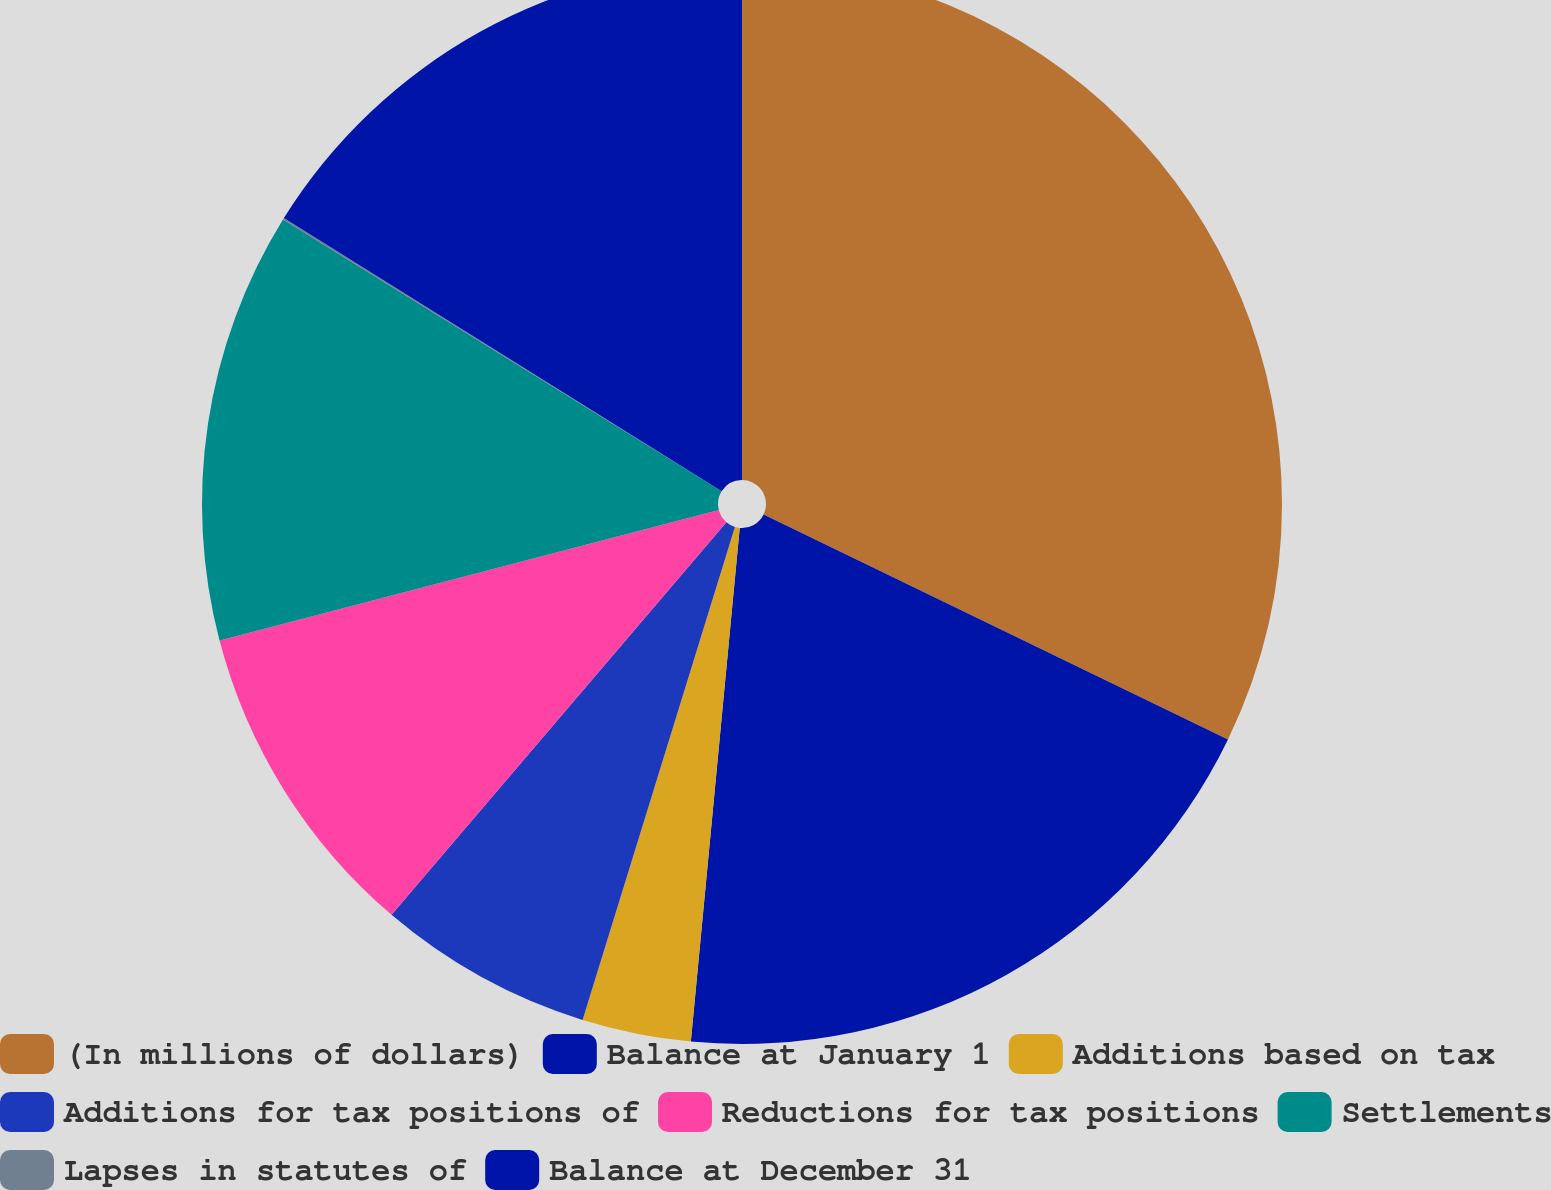Convert chart to OTSL. <chart><loc_0><loc_0><loc_500><loc_500><pie_chart><fcel>(In millions of dollars)<fcel>Balance at January 1<fcel>Additions based on tax<fcel>Additions for tax positions of<fcel>Reductions for tax positions<fcel>Settlements<fcel>Lapses in statutes of<fcel>Balance at December 31<nl><fcel>32.18%<fcel>19.33%<fcel>3.26%<fcel>6.47%<fcel>9.69%<fcel>12.9%<fcel>0.05%<fcel>16.12%<nl></chart> 